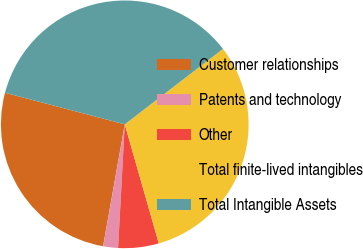Convert chart. <chart><loc_0><loc_0><loc_500><loc_500><pie_chart><fcel>Customer relationships<fcel>Patents and technology<fcel>Other<fcel>Total finite-lived intangibles<fcel>Total Intangible Assets<nl><fcel>26.3%<fcel>1.94%<fcel>5.29%<fcel>30.99%<fcel>35.47%<nl></chart> 